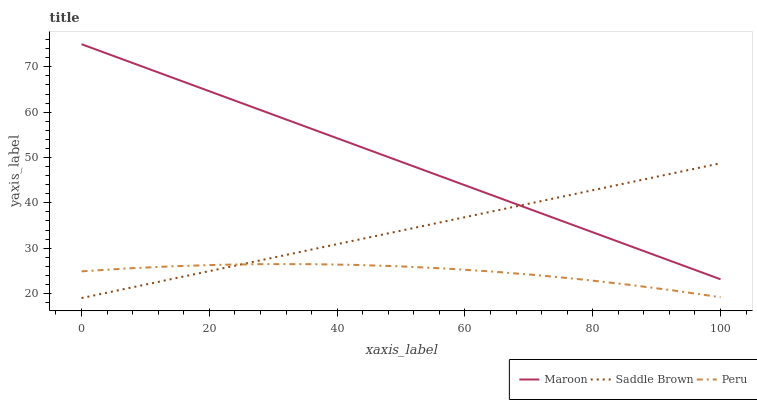Does Peru have the minimum area under the curve?
Answer yes or no. Yes. Does Maroon have the maximum area under the curve?
Answer yes or no. Yes. Does Saddle Brown have the minimum area under the curve?
Answer yes or no. No. Does Saddle Brown have the maximum area under the curve?
Answer yes or no. No. Is Maroon the smoothest?
Answer yes or no. Yes. Is Peru the roughest?
Answer yes or no. Yes. Is Saddle Brown the smoothest?
Answer yes or no. No. Is Saddle Brown the roughest?
Answer yes or no. No. Does Saddle Brown have the lowest value?
Answer yes or no. Yes. Does Maroon have the lowest value?
Answer yes or no. No. Does Maroon have the highest value?
Answer yes or no. Yes. Does Saddle Brown have the highest value?
Answer yes or no. No. Is Peru less than Maroon?
Answer yes or no. Yes. Is Maroon greater than Peru?
Answer yes or no. Yes. Does Saddle Brown intersect Maroon?
Answer yes or no. Yes. Is Saddle Brown less than Maroon?
Answer yes or no. No. Is Saddle Brown greater than Maroon?
Answer yes or no. No. Does Peru intersect Maroon?
Answer yes or no. No. 